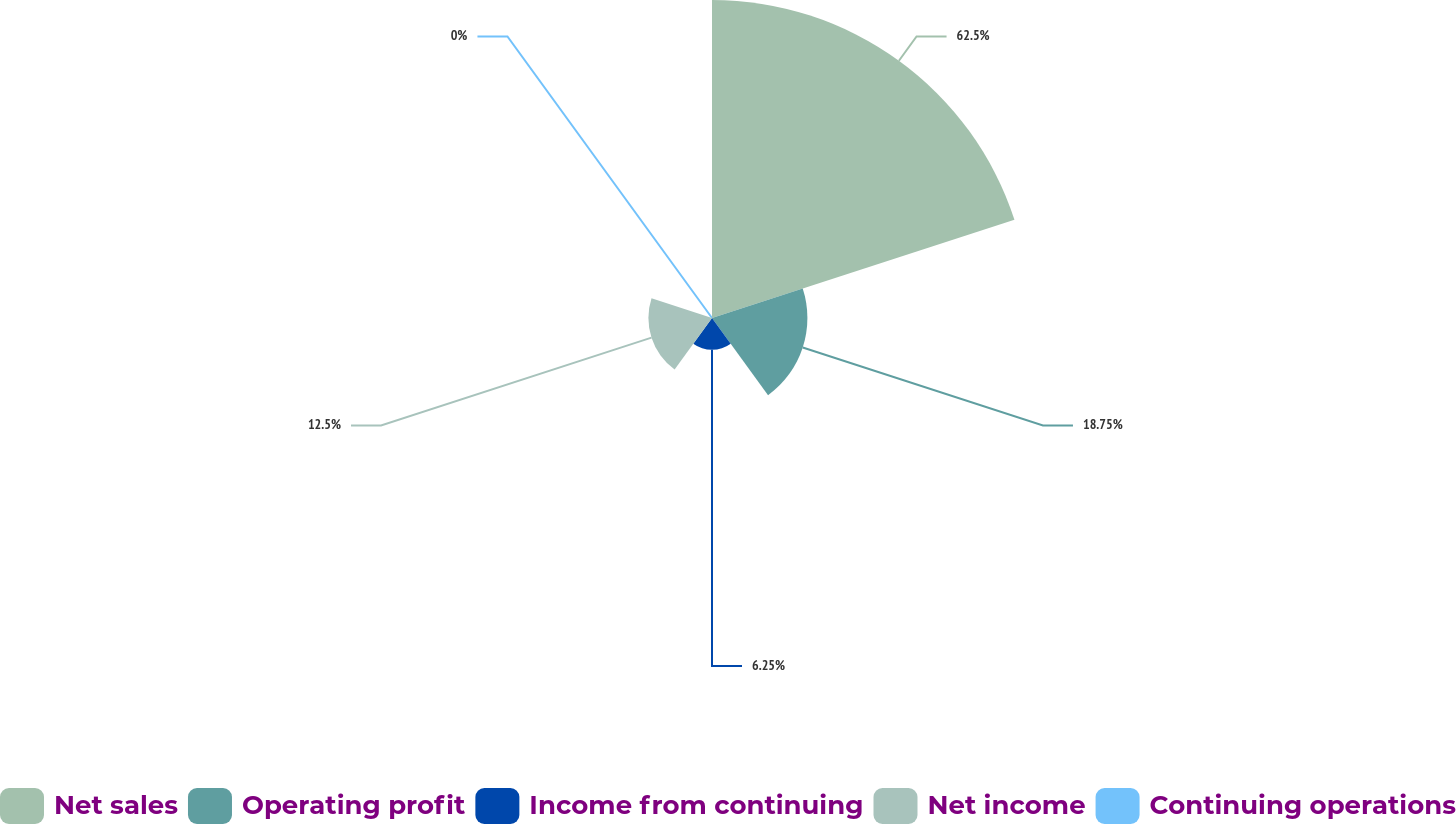Convert chart. <chart><loc_0><loc_0><loc_500><loc_500><pie_chart><fcel>Net sales<fcel>Operating profit<fcel>Income from continuing<fcel>Net income<fcel>Continuing operations<nl><fcel>62.5%<fcel>18.75%<fcel>6.25%<fcel>12.5%<fcel>0.0%<nl></chart> 